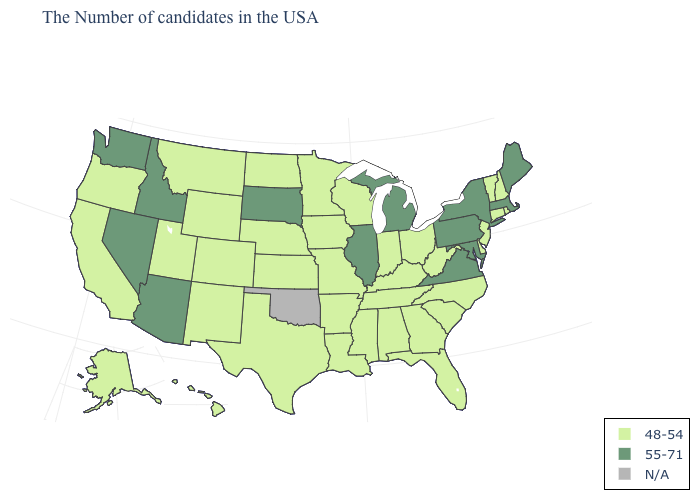Name the states that have a value in the range N/A?
Quick response, please. Oklahoma. Among the states that border Ohio , does Kentucky have the lowest value?
Give a very brief answer. Yes. Does the map have missing data?
Concise answer only. Yes. Which states have the lowest value in the USA?
Keep it brief. Rhode Island, New Hampshire, Vermont, Connecticut, New Jersey, Delaware, North Carolina, South Carolina, West Virginia, Ohio, Florida, Georgia, Kentucky, Indiana, Alabama, Tennessee, Wisconsin, Mississippi, Louisiana, Missouri, Arkansas, Minnesota, Iowa, Kansas, Nebraska, Texas, North Dakota, Wyoming, Colorado, New Mexico, Utah, Montana, California, Oregon, Alaska, Hawaii. Name the states that have a value in the range N/A?
Write a very short answer. Oklahoma. What is the highest value in states that border Massachusetts?
Short answer required. 55-71. What is the highest value in states that border Tennessee?
Keep it brief. 55-71. How many symbols are there in the legend?
Be succinct. 3. Name the states that have a value in the range 55-71?
Give a very brief answer. Maine, Massachusetts, New York, Maryland, Pennsylvania, Virginia, Michigan, Illinois, South Dakota, Arizona, Idaho, Nevada, Washington. What is the value of Missouri?
Quick response, please. 48-54. Among the states that border Indiana , which have the lowest value?
Keep it brief. Ohio, Kentucky. Name the states that have a value in the range N/A?
Answer briefly. Oklahoma. Name the states that have a value in the range 48-54?
Be succinct. Rhode Island, New Hampshire, Vermont, Connecticut, New Jersey, Delaware, North Carolina, South Carolina, West Virginia, Ohio, Florida, Georgia, Kentucky, Indiana, Alabama, Tennessee, Wisconsin, Mississippi, Louisiana, Missouri, Arkansas, Minnesota, Iowa, Kansas, Nebraska, Texas, North Dakota, Wyoming, Colorado, New Mexico, Utah, Montana, California, Oregon, Alaska, Hawaii. Among the states that border New York , which have the lowest value?
Concise answer only. Vermont, Connecticut, New Jersey. Does Arkansas have the lowest value in the USA?
Quick response, please. Yes. 